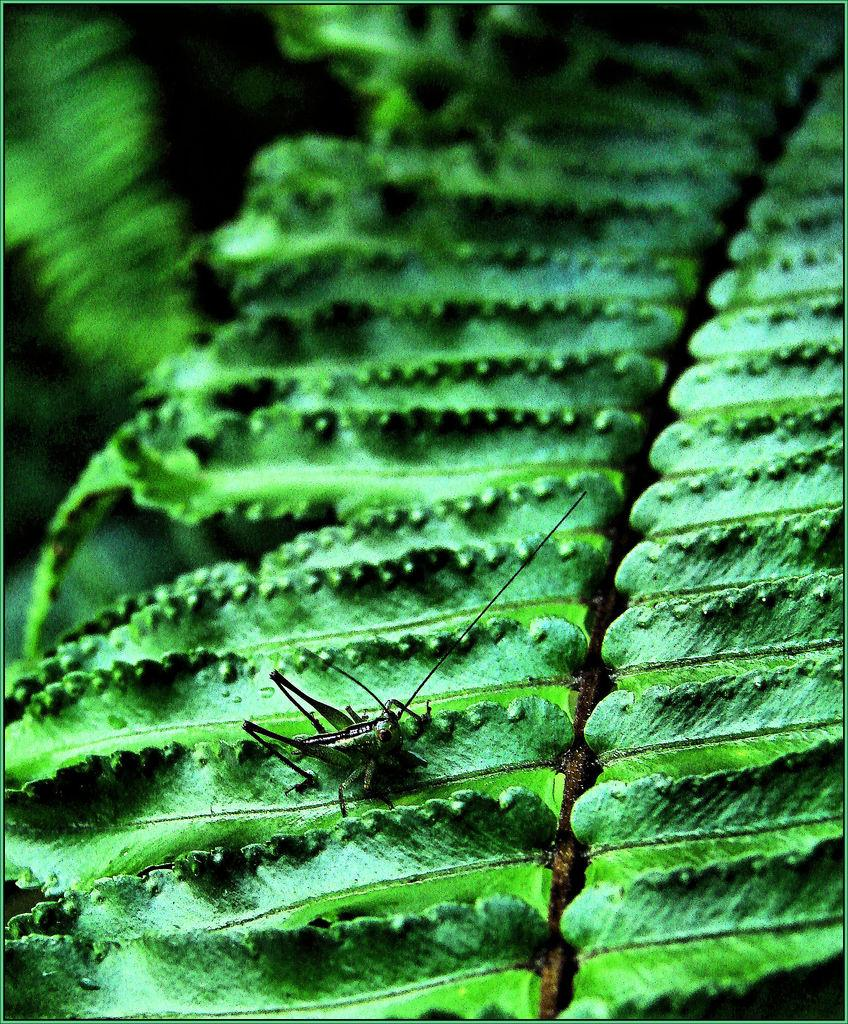What is located in the foreground of the image? There is a leaf in the foreground of the image. Can you describe any additional details about the leaf? There is an insect on the leaf. What type of property can be seen in the background of the image? There is no property visible in the image; it only features a leaf with an insect on it. 